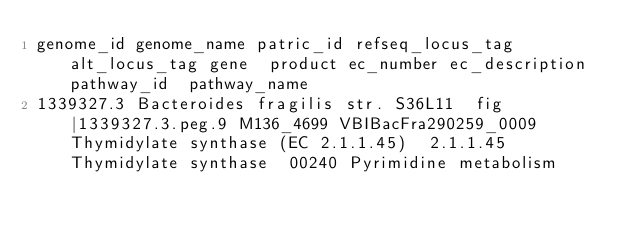Convert code to text. <code><loc_0><loc_0><loc_500><loc_500><_SQL_>genome_id	genome_name	patric_id	refseq_locus_tag	alt_locus_tag	gene	product	ec_number	ec_description	pathway_id	pathway_name
1339327.3	Bacteroides fragilis str. S36L11	fig|1339327.3.peg.9	M136_4699	VBIBacFra290259_0009		Thymidylate synthase (EC 2.1.1.45)	2.1.1.45	Thymidylate synthase	00240	Pyrimidine metabolism</code> 